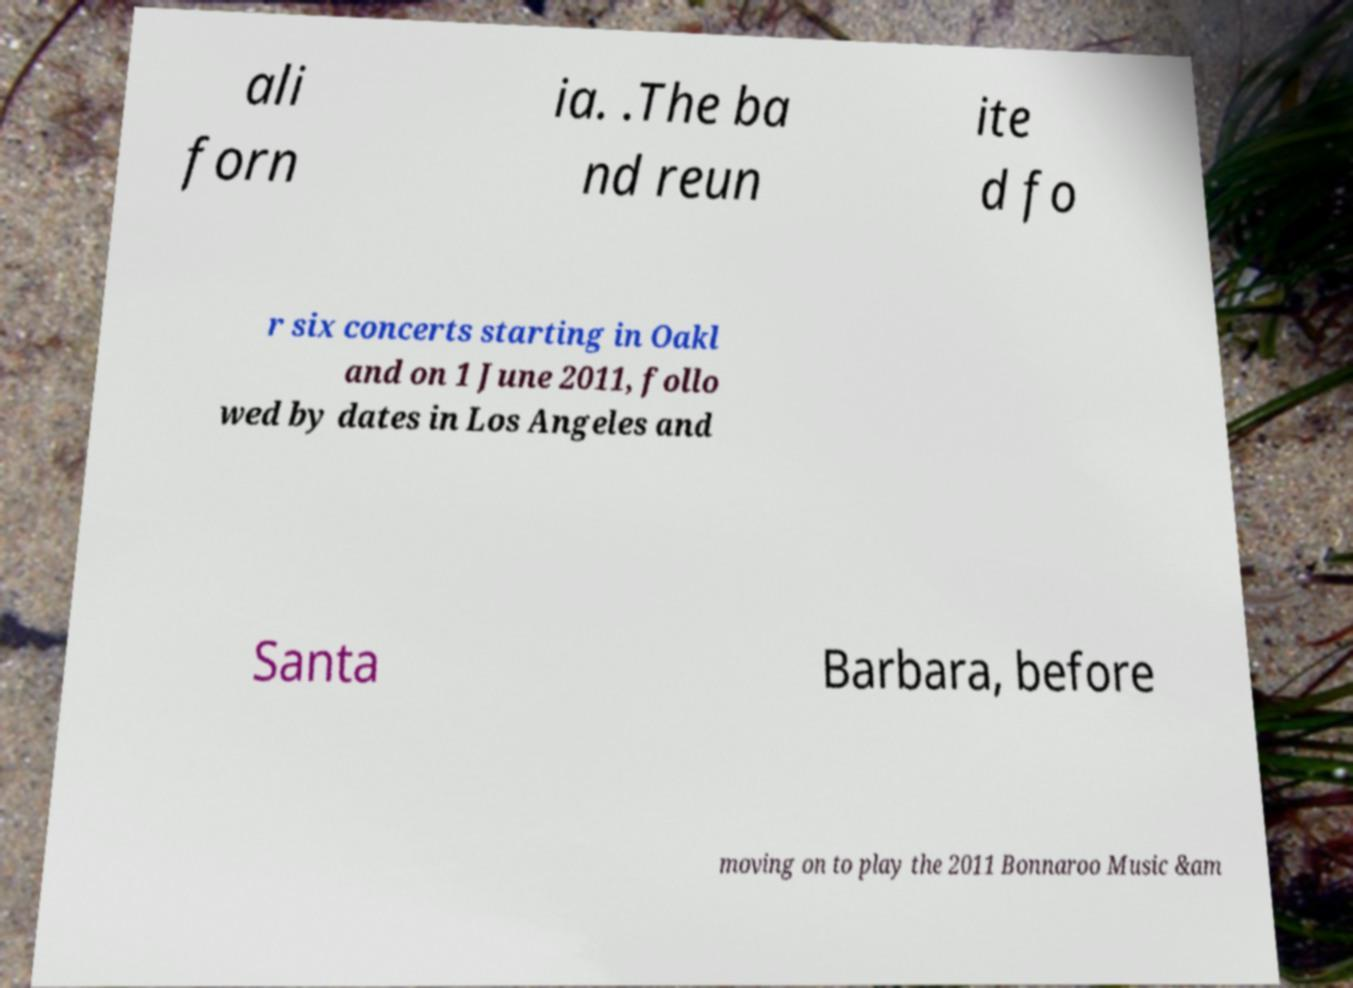Can you accurately transcribe the text from the provided image for me? ali forn ia. .The ba nd reun ite d fo r six concerts starting in Oakl and on 1 June 2011, follo wed by dates in Los Angeles and Santa Barbara, before moving on to play the 2011 Bonnaroo Music &am 